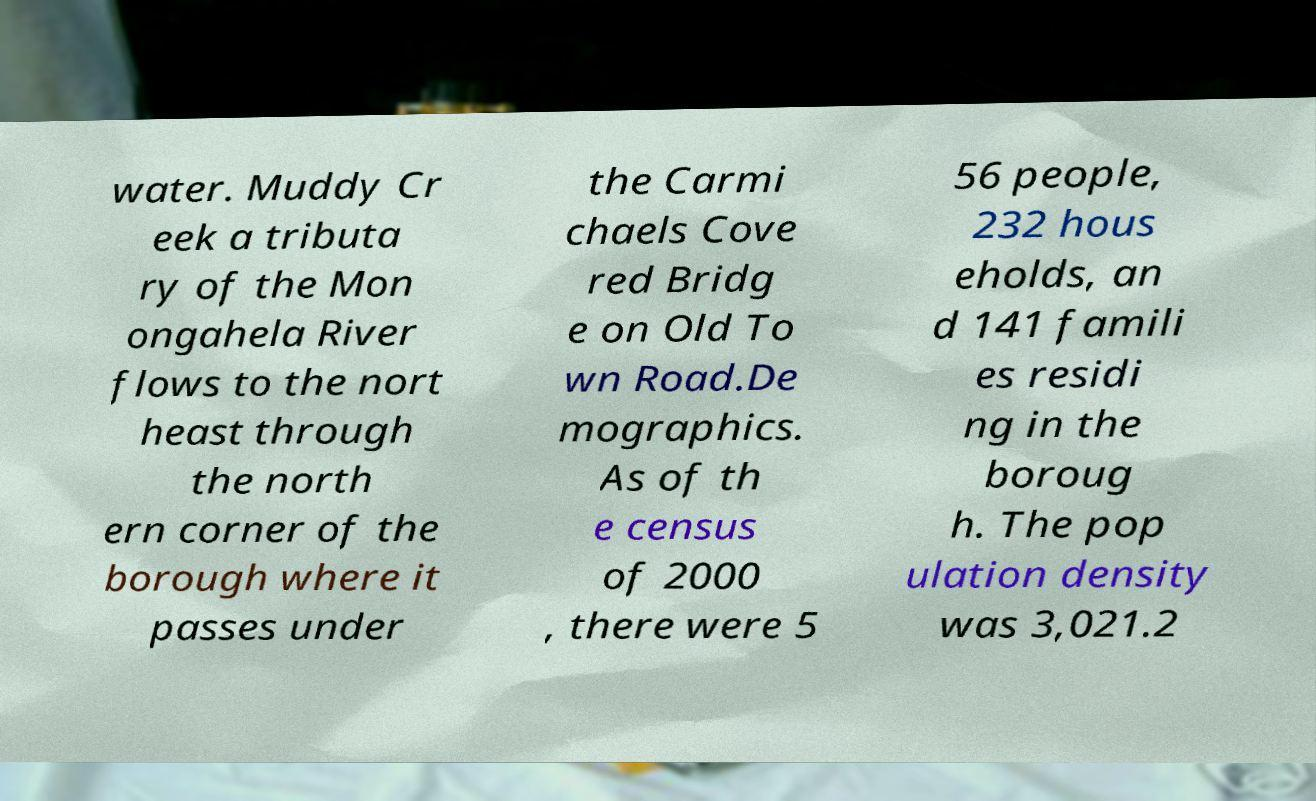Can you accurately transcribe the text from the provided image for me? water. Muddy Cr eek a tributa ry of the Mon ongahela River flows to the nort heast through the north ern corner of the borough where it passes under the Carmi chaels Cove red Bridg e on Old To wn Road.De mographics. As of th e census of 2000 , there were 5 56 people, 232 hous eholds, an d 141 famili es residi ng in the boroug h. The pop ulation density was 3,021.2 